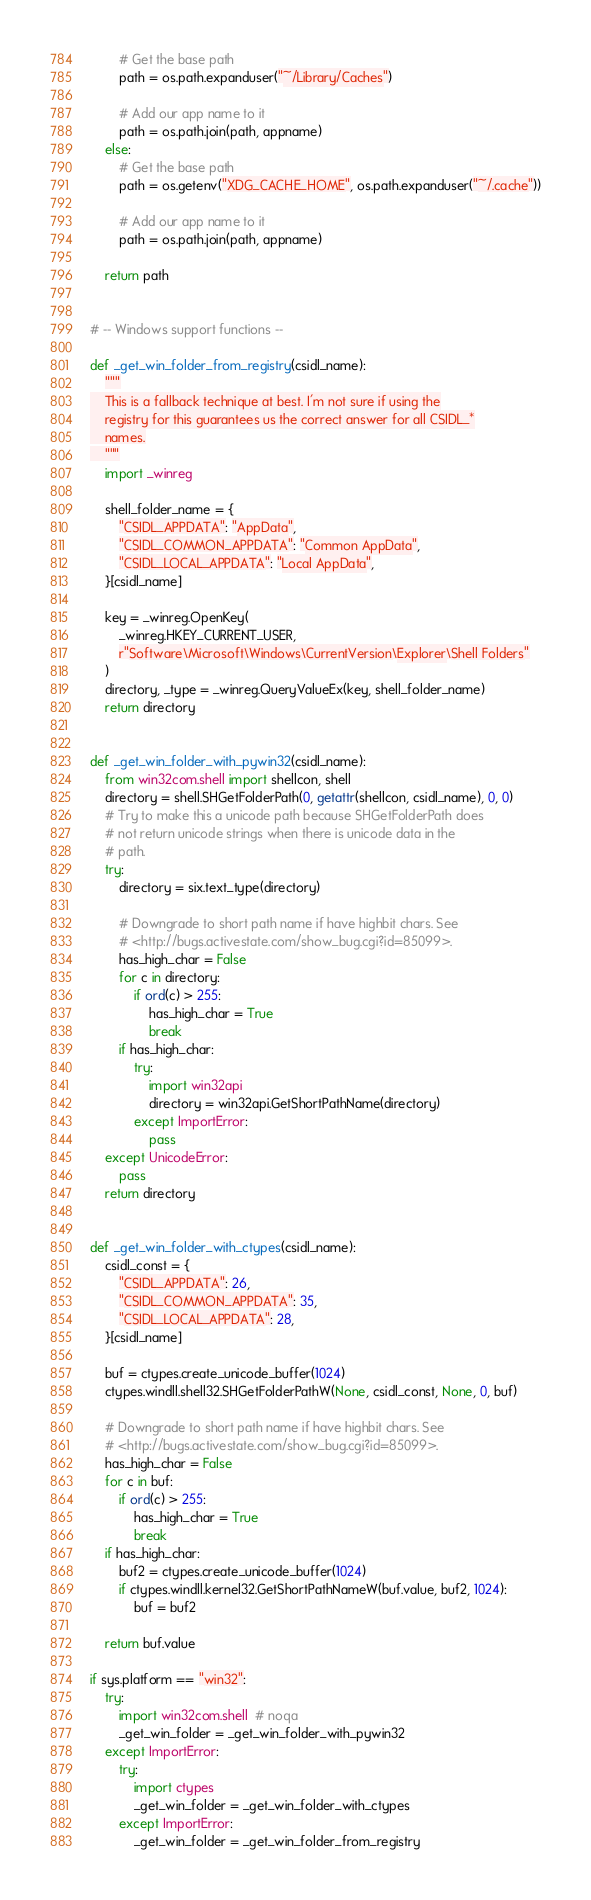<code> <loc_0><loc_0><loc_500><loc_500><_Python_>        # Get the base path
        path = os.path.expanduser("~/Library/Caches")

        # Add our app name to it
        path = os.path.join(path, appname)
    else:
        # Get the base path
        path = os.getenv("XDG_CACHE_HOME", os.path.expanduser("~/.cache"))

        # Add our app name to it
        path = os.path.join(path, appname)

    return path


# -- Windows support functions --

def _get_win_folder_from_registry(csidl_name):
    """
    This is a fallback technique at best. I'm not sure if using the
    registry for this guarantees us the correct answer for all CSIDL_*
    names.
    """
    import _winreg

    shell_folder_name = {
        "CSIDL_APPDATA": "AppData",
        "CSIDL_COMMON_APPDATA": "Common AppData",
        "CSIDL_LOCAL_APPDATA": "Local AppData",
    }[csidl_name]

    key = _winreg.OpenKey(
        _winreg.HKEY_CURRENT_USER,
        r"Software\Microsoft\Windows\CurrentVersion\Explorer\Shell Folders"
    )
    directory, _type = _winreg.QueryValueEx(key, shell_folder_name)
    return directory


def _get_win_folder_with_pywin32(csidl_name):
    from win32com.shell import shellcon, shell
    directory = shell.SHGetFolderPath(0, getattr(shellcon, csidl_name), 0, 0)
    # Try to make this a unicode path because SHGetFolderPath does
    # not return unicode strings when there is unicode data in the
    # path.
    try:
        directory = six.text_type(directory)

        # Downgrade to short path name if have highbit chars. See
        # <http://bugs.activestate.com/show_bug.cgi?id=85099>.
        has_high_char = False
        for c in directory:
            if ord(c) > 255:
                has_high_char = True
                break
        if has_high_char:
            try:
                import win32api
                directory = win32api.GetShortPathName(directory)
            except ImportError:
                pass
    except UnicodeError:
        pass
    return directory


def _get_win_folder_with_ctypes(csidl_name):
    csidl_const = {
        "CSIDL_APPDATA": 26,
        "CSIDL_COMMON_APPDATA": 35,
        "CSIDL_LOCAL_APPDATA": 28,
    }[csidl_name]

    buf = ctypes.create_unicode_buffer(1024)
    ctypes.windll.shell32.SHGetFolderPathW(None, csidl_const, None, 0, buf)

    # Downgrade to short path name if have highbit chars. See
    # <http://bugs.activestate.com/show_bug.cgi?id=85099>.
    has_high_char = False
    for c in buf:
        if ord(c) > 255:
            has_high_char = True
            break
    if has_high_char:
        buf2 = ctypes.create_unicode_buffer(1024)
        if ctypes.windll.kernel32.GetShortPathNameW(buf.value, buf2, 1024):
            buf = buf2

    return buf.value

if sys.platform == "win32":
    try:
        import win32com.shell  # noqa
        _get_win_folder = _get_win_folder_with_pywin32
    except ImportError:
        try:
            import ctypes
            _get_win_folder = _get_win_folder_with_ctypes
        except ImportError:
            _get_win_folder = _get_win_folder_from_registry
</code> 